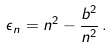<formula> <loc_0><loc_0><loc_500><loc_500>\epsilon _ { n } = n ^ { 2 } - \frac { b ^ { 2 } } { n ^ { 2 } } \, .</formula> 